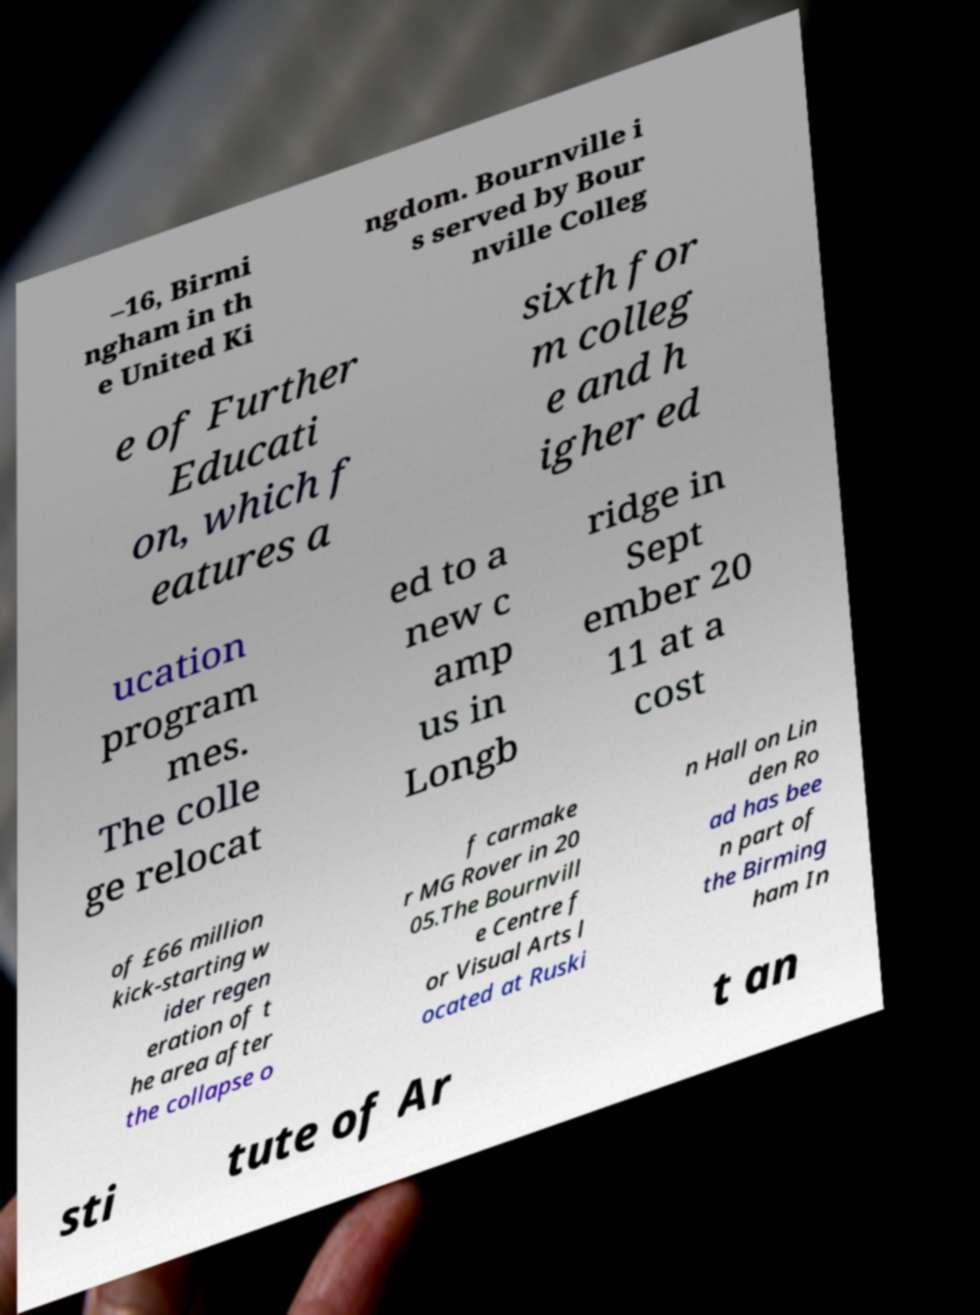Please read and relay the text visible in this image. What does it say? –16, Birmi ngham in th e United Ki ngdom. Bournville i s served by Bour nville Colleg e of Further Educati on, which f eatures a sixth for m colleg e and h igher ed ucation program mes. The colle ge relocat ed to a new c amp us in Longb ridge in Sept ember 20 11 at a cost of £66 million kick-starting w ider regen eration of t he area after the collapse o f carmake r MG Rover in 20 05.The Bournvill e Centre f or Visual Arts l ocated at Ruski n Hall on Lin den Ro ad has bee n part of the Birming ham In sti tute of Ar t an 